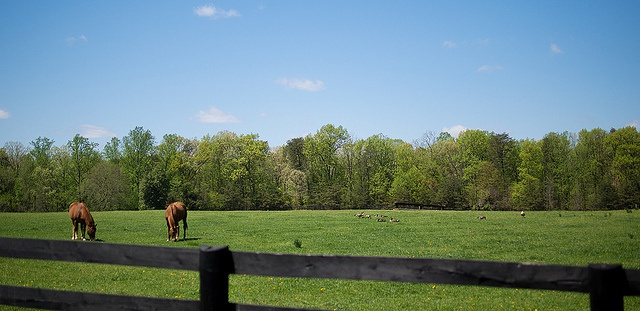Describe the objects in this image and their specific colors. I can see horse in gray, black, olive, salmon, and maroon tones, horse in gray, black, maroon, olive, and brown tones, bird in gray, olive, and darkgreen tones, bird in gray, olive, and darkgreen tones, and bird in gray, darkgreen, olive, and black tones in this image. 